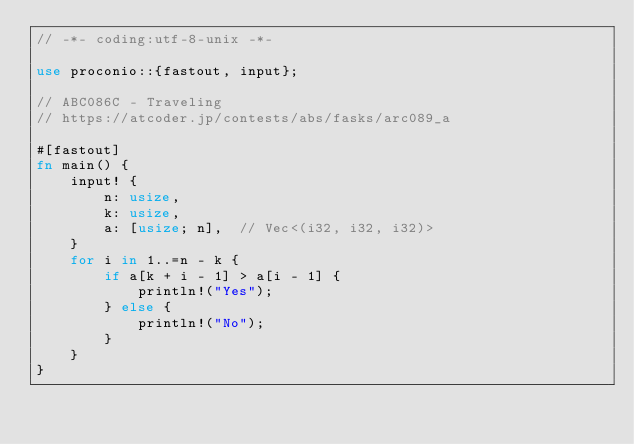Convert code to text. <code><loc_0><loc_0><loc_500><loc_500><_Rust_>// -*- coding:utf-8-unix -*-

use proconio::{fastout, input};

// ABC086C - Traveling
// https://atcoder.jp/contests/abs/fasks/arc089_a

#[fastout]
fn main() {
    input! {
        n: usize,
        k: usize,
        a: [usize; n],  // Vec<(i32, i32, i32)>
    }
    for i in 1..=n - k {
        if a[k + i - 1] > a[i - 1] {
            println!("Yes");
        } else {
            println!("No");
        }
    }
}
</code> 